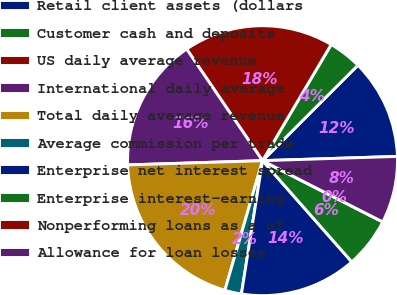<chart> <loc_0><loc_0><loc_500><loc_500><pie_chart><fcel>Retail client assets (dollars<fcel>Customer cash and deposits<fcel>US daily average revenue<fcel>International daily average<fcel>Total daily average revenue<fcel>Average commission per trade<fcel>Enterprise net interest spread<fcel>Enterprise interest-earning<fcel>Nonperforming loans as a of<fcel>Allowance for loan losses<nl><fcel>12.0%<fcel>4.0%<fcel>18.0%<fcel>16.0%<fcel>20.0%<fcel>2.0%<fcel>14.0%<fcel>6.0%<fcel>0.0%<fcel>8.0%<nl></chart> 